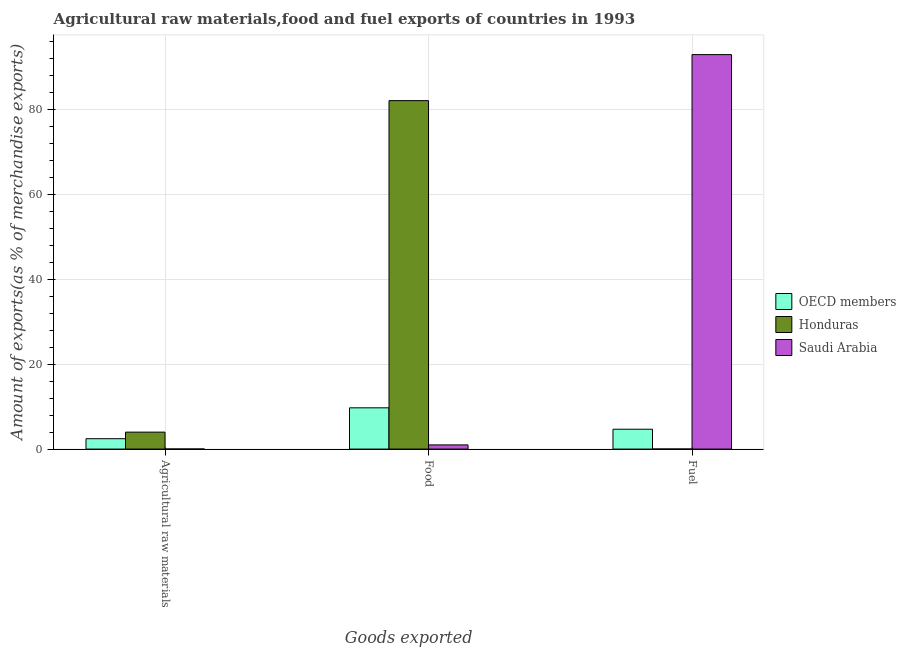How many different coloured bars are there?
Your answer should be compact. 3. How many groups of bars are there?
Your answer should be compact. 3. How many bars are there on the 2nd tick from the left?
Your answer should be very brief. 3. How many bars are there on the 2nd tick from the right?
Ensure brevity in your answer.  3. What is the label of the 3rd group of bars from the left?
Offer a very short reply. Fuel. What is the percentage of raw materials exports in OECD members?
Offer a terse response. 2.44. Across all countries, what is the maximum percentage of fuel exports?
Your answer should be compact. 92.87. Across all countries, what is the minimum percentage of fuel exports?
Make the answer very short. 0.01. In which country was the percentage of fuel exports maximum?
Ensure brevity in your answer.  Saudi Arabia. In which country was the percentage of fuel exports minimum?
Offer a very short reply. Honduras. What is the total percentage of food exports in the graph?
Provide a succinct answer. 92.72. What is the difference between the percentage of raw materials exports in OECD members and that in Saudi Arabia?
Ensure brevity in your answer.  2.42. What is the difference between the percentage of food exports in Honduras and the percentage of raw materials exports in OECD members?
Make the answer very short. 79.59. What is the average percentage of raw materials exports per country?
Keep it short and to the point. 2.15. What is the difference between the percentage of fuel exports and percentage of raw materials exports in Saudi Arabia?
Give a very brief answer. 92.85. In how many countries, is the percentage of raw materials exports greater than 4 %?
Ensure brevity in your answer.  0. What is the ratio of the percentage of food exports in Saudi Arabia to that in Honduras?
Provide a succinct answer. 0.01. Is the percentage of fuel exports in Honduras less than that in OECD members?
Ensure brevity in your answer.  Yes. Is the difference between the percentage of fuel exports in OECD members and Honduras greater than the difference between the percentage of raw materials exports in OECD members and Honduras?
Provide a short and direct response. Yes. What is the difference between the highest and the second highest percentage of fuel exports?
Ensure brevity in your answer.  88.2. What is the difference between the highest and the lowest percentage of fuel exports?
Your answer should be very brief. 92.86. Is the sum of the percentage of food exports in Honduras and OECD members greater than the maximum percentage of raw materials exports across all countries?
Keep it short and to the point. Yes. What does the 1st bar from the left in Fuel represents?
Make the answer very short. OECD members. What does the 1st bar from the right in Agricultural raw materials represents?
Provide a succinct answer. Saudi Arabia. How many countries are there in the graph?
Ensure brevity in your answer.  3. Are the values on the major ticks of Y-axis written in scientific E-notation?
Ensure brevity in your answer.  No. Does the graph contain any zero values?
Offer a very short reply. No. Does the graph contain grids?
Your answer should be very brief. Yes. Where does the legend appear in the graph?
Provide a short and direct response. Center right. How many legend labels are there?
Give a very brief answer. 3. How are the legend labels stacked?
Offer a very short reply. Vertical. What is the title of the graph?
Your answer should be very brief. Agricultural raw materials,food and fuel exports of countries in 1993. What is the label or title of the X-axis?
Your answer should be compact. Goods exported. What is the label or title of the Y-axis?
Your answer should be very brief. Amount of exports(as % of merchandise exports). What is the Amount of exports(as % of merchandise exports) of OECD members in Agricultural raw materials?
Offer a very short reply. 2.44. What is the Amount of exports(as % of merchandise exports) in Honduras in Agricultural raw materials?
Provide a short and direct response. 3.99. What is the Amount of exports(as % of merchandise exports) of Saudi Arabia in Agricultural raw materials?
Offer a very short reply. 0.02. What is the Amount of exports(as % of merchandise exports) of OECD members in Food?
Ensure brevity in your answer.  9.71. What is the Amount of exports(as % of merchandise exports) of Honduras in Food?
Make the answer very short. 82.03. What is the Amount of exports(as % of merchandise exports) of Saudi Arabia in Food?
Provide a short and direct response. 0.98. What is the Amount of exports(as % of merchandise exports) of OECD members in Fuel?
Keep it short and to the point. 4.67. What is the Amount of exports(as % of merchandise exports) in Honduras in Fuel?
Offer a very short reply. 0.01. What is the Amount of exports(as % of merchandise exports) in Saudi Arabia in Fuel?
Offer a terse response. 92.87. Across all Goods exported, what is the maximum Amount of exports(as % of merchandise exports) in OECD members?
Offer a very short reply. 9.71. Across all Goods exported, what is the maximum Amount of exports(as % of merchandise exports) of Honduras?
Provide a succinct answer. 82.03. Across all Goods exported, what is the maximum Amount of exports(as % of merchandise exports) in Saudi Arabia?
Your answer should be compact. 92.87. Across all Goods exported, what is the minimum Amount of exports(as % of merchandise exports) of OECD members?
Offer a very short reply. 2.44. Across all Goods exported, what is the minimum Amount of exports(as % of merchandise exports) in Honduras?
Offer a terse response. 0.01. Across all Goods exported, what is the minimum Amount of exports(as % of merchandise exports) in Saudi Arabia?
Your response must be concise. 0.02. What is the total Amount of exports(as % of merchandise exports) of OECD members in the graph?
Offer a very short reply. 16.83. What is the total Amount of exports(as % of merchandise exports) of Honduras in the graph?
Ensure brevity in your answer.  86.03. What is the total Amount of exports(as % of merchandise exports) in Saudi Arabia in the graph?
Make the answer very short. 93.87. What is the difference between the Amount of exports(as % of merchandise exports) in OECD members in Agricultural raw materials and that in Food?
Offer a very short reply. -7.27. What is the difference between the Amount of exports(as % of merchandise exports) in Honduras in Agricultural raw materials and that in Food?
Your answer should be compact. -78.04. What is the difference between the Amount of exports(as % of merchandise exports) in Saudi Arabia in Agricultural raw materials and that in Food?
Offer a very short reply. -0.96. What is the difference between the Amount of exports(as % of merchandise exports) of OECD members in Agricultural raw materials and that in Fuel?
Your answer should be very brief. -2.23. What is the difference between the Amount of exports(as % of merchandise exports) in Honduras in Agricultural raw materials and that in Fuel?
Offer a terse response. 3.98. What is the difference between the Amount of exports(as % of merchandise exports) of Saudi Arabia in Agricultural raw materials and that in Fuel?
Keep it short and to the point. -92.85. What is the difference between the Amount of exports(as % of merchandise exports) in OECD members in Food and that in Fuel?
Provide a succinct answer. 5.04. What is the difference between the Amount of exports(as % of merchandise exports) in Honduras in Food and that in Fuel?
Make the answer very short. 82.02. What is the difference between the Amount of exports(as % of merchandise exports) in Saudi Arabia in Food and that in Fuel?
Ensure brevity in your answer.  -91.89. What is the difference between the Amount of exports(as % of merchandise exports) of OECD members in Agricultural raw materials and the Amount of exports(as % of merchandise exports) of Honduras in Food?
Ensure brevity in your answer.  -79.59. What is the difference between the Amount of exports(as % of merchandise exports) of OECD members in Agricultural raw materials and the Amount of exports(as % of merchandise exports) of Saudi Arabia in Food?
Offer a very short reply. 1.46. What is the difference between the Amount of exports(as % of merchandise exports) in Honduras in Agricultural raw materials and the Amount of exports(as % of merchandise exports) in Saudi Arabia in Food?
Offer a very short reply. 3.01. What is the difference between the Amount of exports(as % of merchandise exports) of OECD members in Agricultural raw materials and the Amount of exports(as % of merchandise exports) of Honduras in Fuel?
Provide a succinct answer. 2.43. What is the difference between the Amount of exports(as % of merchandise exports) in OECD members in Agricultural raw materials and the Amount of exports(as % of merchandise exports) in Saudi Arabia in Fuel?
Your response must be concise. -90.43. What is the difference between the Amount of exports(as % of merchandise exports) in Honduras in Agricultural raw materials and the Amount of exports(as % of merchandise exports) in Saudi Arabia in Fuel?
Ensure brevity in your answer.  -88.88. What is the difference between the Amount of exports(as % of merchandise exports) in OECD members in Food and the Amount of exports(as % of merchandise exports) in Honduras in Fuel?
Give a very brief answer. 9.7. What is the difference between the Amount of exports(as % of merchandise exports) in OECD members in Food and the Amount of exports(as % of merchandise exports) in Saudi Arabia in Fuel?
Give a very brief answer. -83.16. What is the difference between the Amount of exports(as % of merchandise exports) of Honduras in Food and the Amount of exports(as % of merchandise exports) of Saudi Arabia in Fuel?
Offer a terse response. -10.84. What is the average Amount of exports(as % of merchandise exports) in OECD members per Goods exported?
Your response must be concise. 5.61. What is the average Amount of exports(as % of merchandise exports) of Honduras per Goods exported?
Offer a terse response. 28.68. What is the average Amount of exports(as % of merchandise exports) in Saudi Arabia per Goods exported?
Make the answer very short. 31.29. What is the difference between the Amount of exports(as % of merchandise exports) of OECD members and Amount of exports(as % of merchandise exports) of Honduras in Agricultural raw materials?
Keep it short and to the point. -1.55. What is the difference between the Amount of exports(as % of merchandise exports) in OECD members and Amount of exports(as % of merchandise exports) in Saudi Arabia in Agricultural raw materials?
Provide a succinct answer. 2.42. What is the difference between the Amount of exports(as % of merchandise exports) of Honduras and Amount of exports(as % of merchandise exports) of Saudi Arabia in Agricultural raw materials?
Your answer should be very brief. 3.97. What is the difference between the Amount of exports(as % of merchandise exports) of OECD members and Amount of exports(as % of merchandise exports) of Honduras in Food?
Keep it short and to the point. -72.32. What is the difference between the Amount of exports(as % of merchandise exports) of OECD members and Amount of exports(as % of merchandise exports) of Saudi Arabia in Food?
Your answer should be very brief. 8.73. What is the difference between the Amount of exports(as % of merchandise exports) in Honduras and Amount of exports(as % of merchandise exports) in Saudi Arabia in Food?
Ensure brevity in your answer.  81.05. What is the difference between the Amount of exports(as % of merchandise exports) of OECD members and Amount of exports(as % of merchandise exports) of Honduras in Fuel?
Your answer should be very brief. 4.66. What is the difference between the Amount of exports(as % of merchandise exports) in OECD members and Amount of exports(as % of merchandise exports) in Saudi Arabia in Fuel?
Your answer should be very brief. -88.2. What is the difference between the Amount of exports(as % of merchandise exports) of Honduras and Amount of exports(as % of merchandise exports) of Saudi Arabia in Fuel?
Your answer should be very brief. -92.86. What is the ratio of the Amount of exports(as % of merchandise exports) in OECD members in Agricultural raw materials to that in Food?
Your response must be concise. 0.25. What is the ratio of the Amount of exports(as % of merchandise exports) of Honduras in Agricultural raw materials to that in Food?
Provide a succinct answer. 0.05. What is the ratio of the Amount of exports(as % of merchandise exports) of Saudi Arabia in Agricultural raw materials to that in Food?
Make the answer very short. 0.02. What is the ratio of the Amount of exports(as % of merchandise exports) of OECD members in Agricultural raw materials to that in Fuel?
Ensure brevity in your answer.  0.52. What is the ratio of the Amount of exports(as % of merchandise exports) of Honduras in Agricultural raw materials to that in Fuel?
Your answer should be compact. 375.92. What is the ratio of the Amount of exports(as % of merchandise exports) in Saudi Arabia in Agricultural raw materials to that in Fuel?
Offer a terse response. 0. What is the ratio of the Amount of exports(as % of merchandise exports) of OECD members in Food to that in Fuel?
Your response must be concise. 2.08. What is the ratio of the Amount of exports(as % of merchandise exports) in Honduras in Food to that in Fuel?
Your answer should be compact. 7732.83. What is the ratio of the Amount of exports(as % of merchandise exports) in Saudi Arabia in Food to that in Fuel?
Your answer should be compact. 0.01. What is the difference between the highest and the second highest Amount of exports(as % of merchandise exports) of OECD members?
Provide a short and direct response. 5.04. What is the difference between the highest and the second highest Amount of exports(as % of merchandise exports) of Honduras?
Your answer should be very brief. 78.04. What is the difference between the highest and the second highest Amount of exports(as % of merchandise exports) in Saudi Arabia?
Your response must be concise. 91.89. What is the difference between the highest and the lowest Amount of exports(as % of merchandise exports) of OECD members?
Your response must be concise. 7.27. What is the difference between the highest and the lowest Amount of exports(as % of merchandise exports) of Honduras?
Provide a short and direct response. 82.02. What is the difference between the highest and the lowest Amount of exports(as % of merchandise exports) in Saudi Arabia?
Offer a terse response. 92.85. 